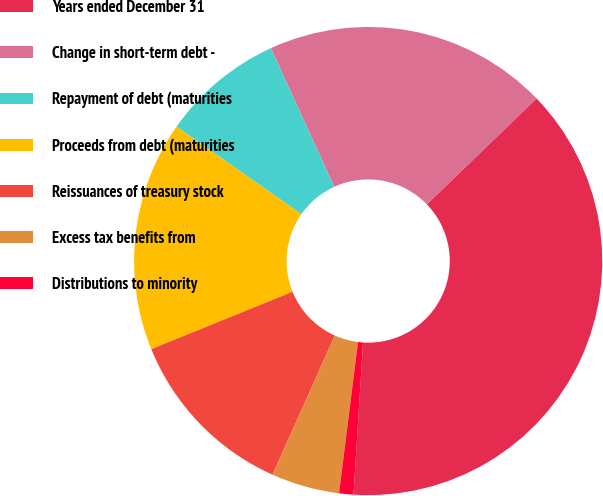<chart> <loc_0><loc_0><loc_500><loc_500><pie_chart><fcel>Years ended December 31<fcel>Change in short-term debt -<fcel>Repayment of debt (maturities<fcel>Proceeds from debt (maturities<fcel>Reissuances of treasury stock<fcel>Excess tax benefits from<fcel>Distributions to minority<nl><fcel>38.22%<fcel>19.6%<fcel>8.44%<fcel>15.88%<fcel>12.16%<fcel>4.71%<fcel>0.99%<nl></chart> 